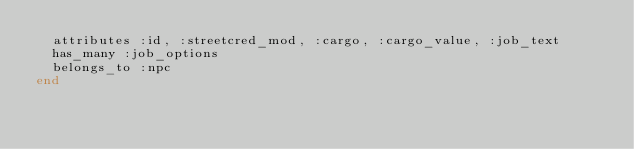<code> <loc_0><loc_0><loc_500><loc_500><_Ruby_>  attributes :id, :streetcred_mod, :cargo, :cargo_value, :job_text
  has_many :job_options
  belongs_to :npc
end
</code> 